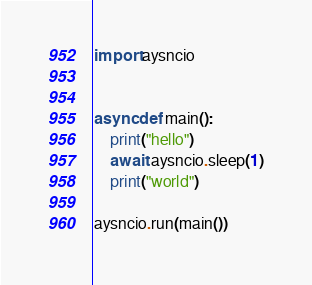Convert code to text. <code><loc_0><loc_0><loc_500><loc_500><_Python_>import aysncio


async def main():
    print("hello")
    await aysncio.sleep(1)
    print("world")

aysncio.run(main())</code> 